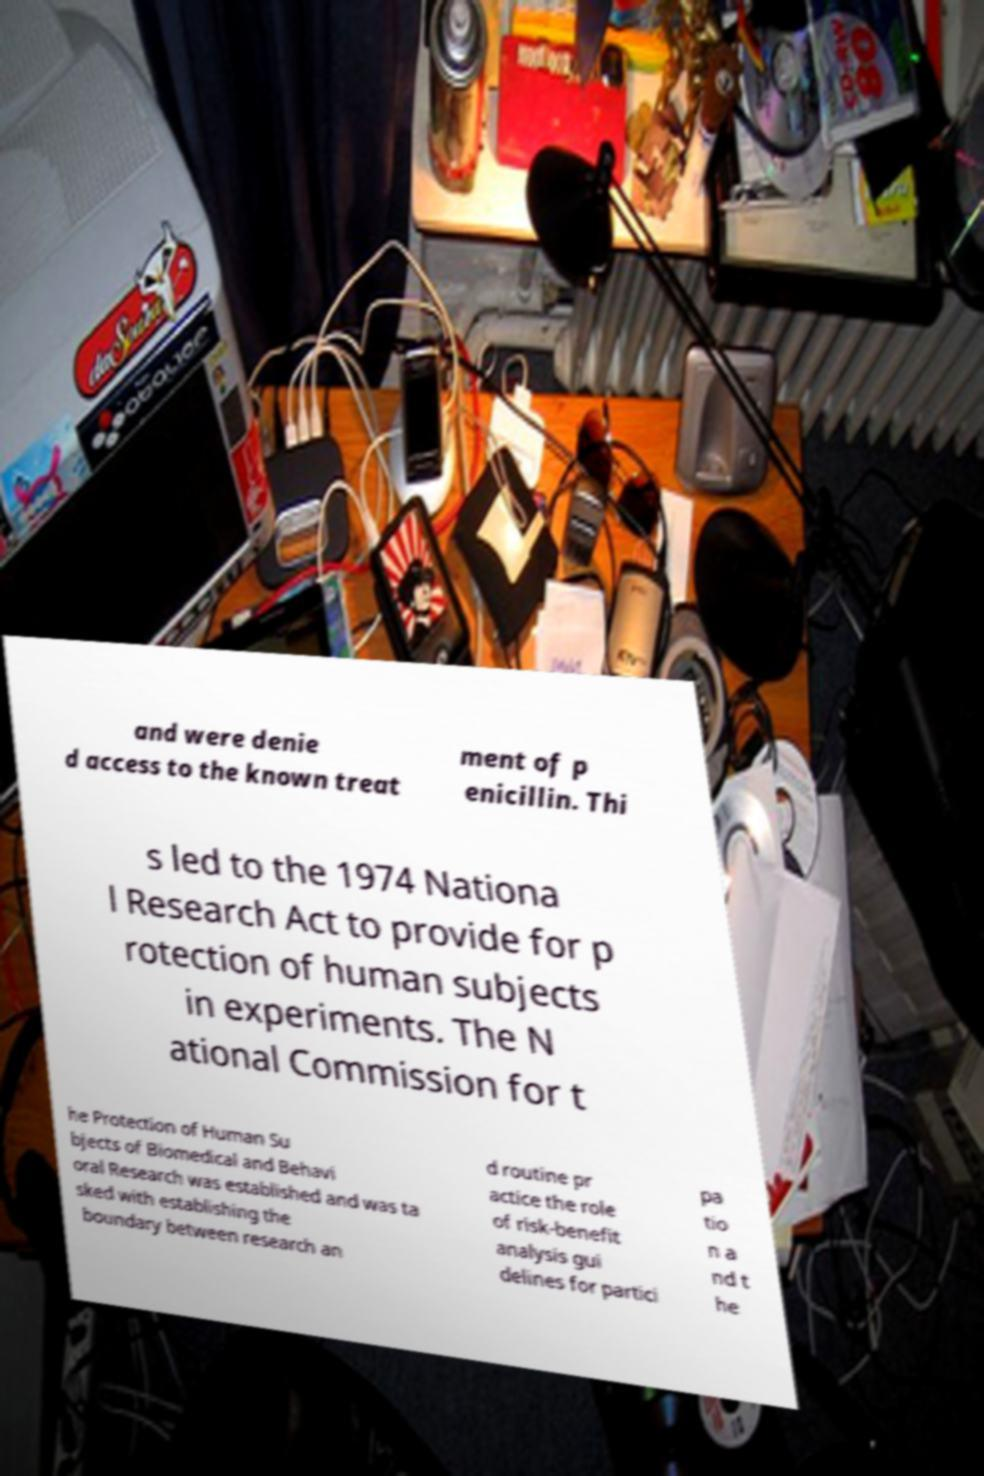What messages or text are displayed in this image? I need them in a readable, typed format. and were denie d access to the known treat ment of p enicillin. Thi s led to the 1974 Nationa l Research Act to provide for p rotection of human subjects in experiments. The N ational Commission for t he Protection of Human Su bjects of Biomedical and Behavi oral Research was established and was ta sked with establishing the boundary between research an d routine pr actice the role of risk-benefit analysis gui delines for partici pa tio n a nd t he 